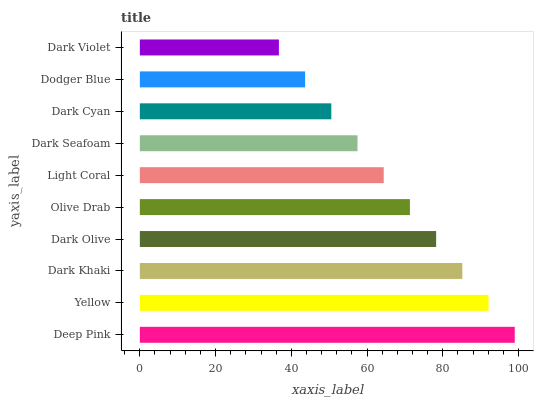Is Dark Violet the minimum?
Answer yes or no. Yes. Is Deep Pink the maximum?
Answer yes or no. Yes. Is Yellow the minimum?
Answer yes or no. No. Is Yellow the maximum?
Answer yes or no. No. Is Deep Pink greater than Yellow?
Answer yes or no. Yes. Is Yellow less than Deep Pink?
Answer yes or no. Yes. Is Yellow greater than Deep Pink?
Answer yes or no. No. Is Deep Pink less than Yellow?
Answer yes or no. No. Is Olive Drab the high median?
Answer yes or no. Yes. Is Light Coral the low median?
Answer yes or no. Yes. Is Dodger Blue the high median?
Answer yes or no. No. Is Olive Drab the low median?
Answer yes or no. No. 